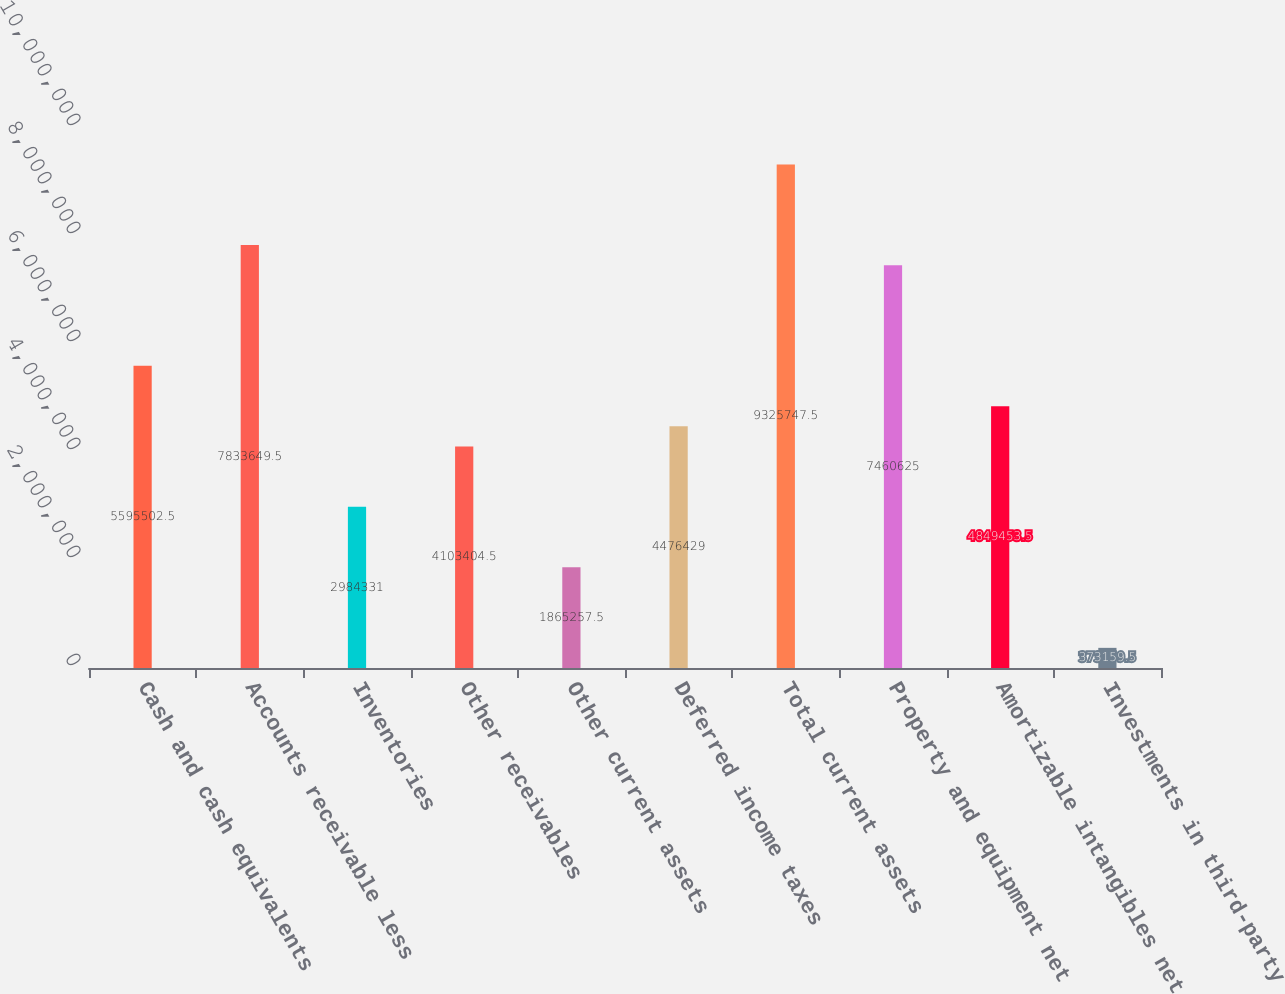Convert chart to OTSL. <chart><loc_0><loc_0><loc_500><loc_500><bar_chart><fcel>Cash and cash equivalents<fcel>Accounts receivable less<fcel>Inventories<fcel>Other receivables<fcel>Other current assets<fcel>Deferred income taxes<fcel>Total current assets<fcel>Property and equipment net<fcel>Amortizable intangibles net<fcel>Investments in third-party<nl><fcel>5.5955e+06<fcel>7.83365e+06<fcel>2.98433e+06<fcel>4.1034e+06<fcel>1.86526e+06<fcel>4.47643e+06<fcel>9.32575e+06<fcel>7.46062e+06<fcel>4.84945e+06<fcel>373160<nl></chart> 